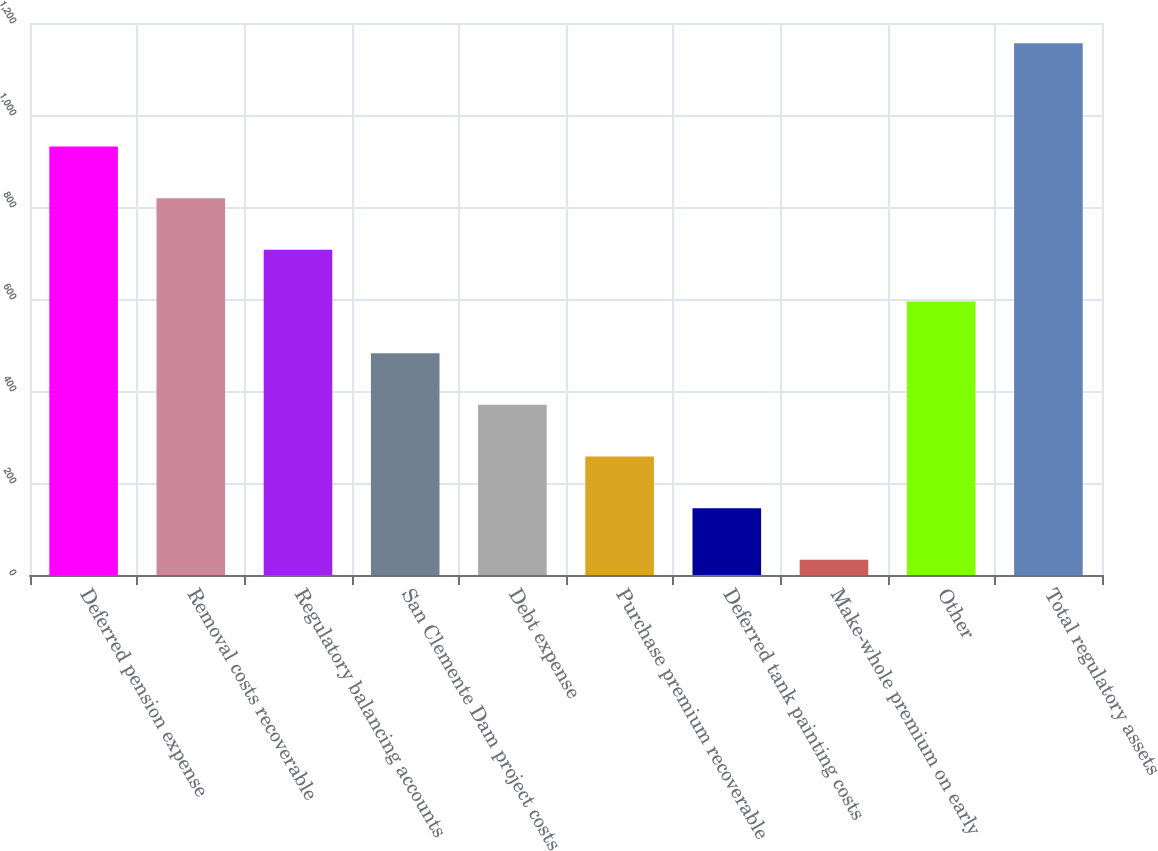<chart> <loc_0><loc_0><loc_500><loc_500><bar_chart><fcel>Deferred pension expense<fcel>Removal costs recoverable<fcel>Regulatory balancing accounts<fcel>San Clemente Dam project costs<fcel>Debt expense<fcel>Purchase premium recoverable<fcel>Deferred tank painting costs<fcel>Make-whole premium on early<fcel>Other<fcel>Total regulatory assets<nl><fcel>931.4<fcel>819.1<fcel>706.8<fcel>482.2<fcel>369.9<fcel>257.6<fcel>145.3<fcel>33<fcel>594.5<fcel>1156<nl></chart> 